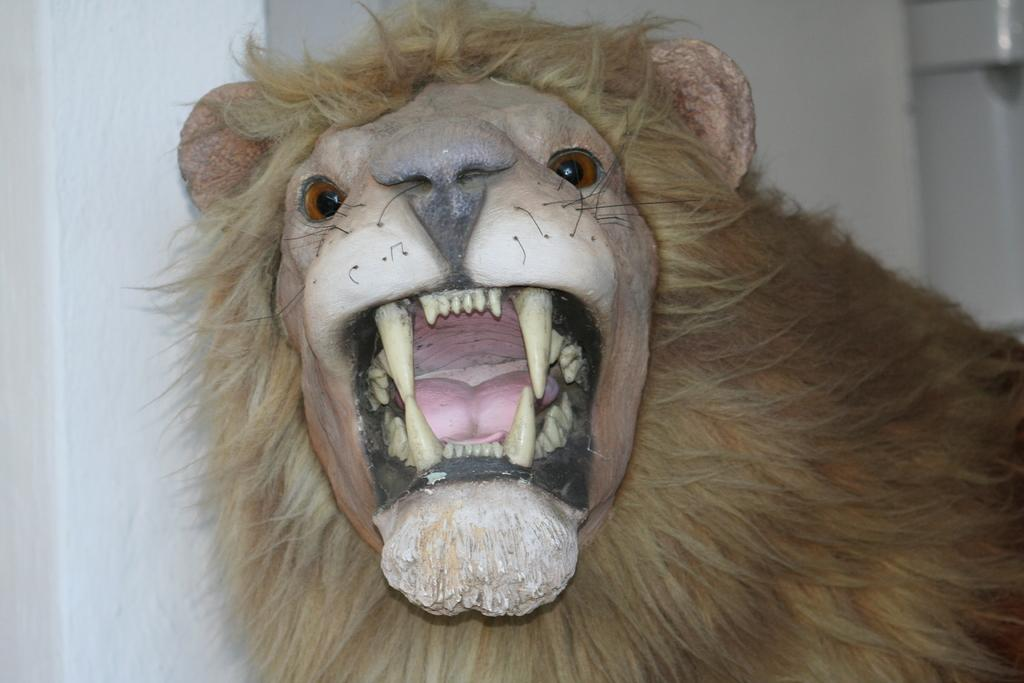What type of living creature is present in the image? There is an animal in the image. What can be seen in the background of the image? There is a wall in the background of the image. What type of fog can be seen surrounding the animal in the image? There is no fog present in the image; it is a clear image of the animal. 